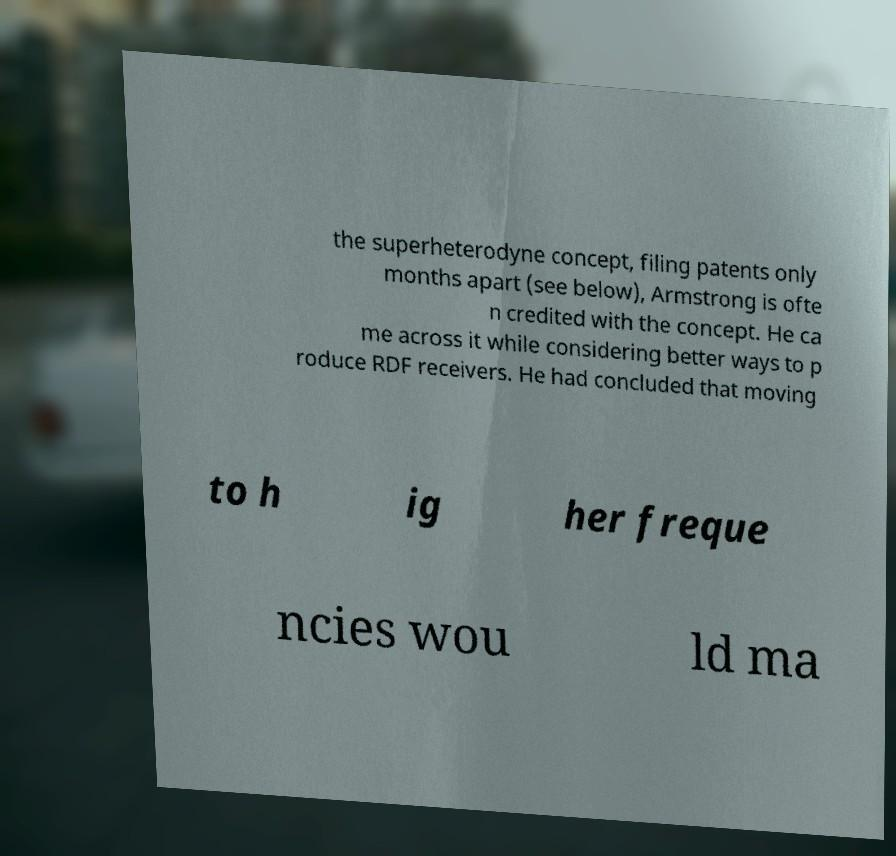Can you accurately transcribe the text from the provided image for me? the superheterodyne concept, filing patents only months apart (see below), Armstrong is ofte n credited with the concept. He ca me across it while considering better ways to p roduce RDF receivers. He had concluded that moving to h ig her freque ncies wou ld ma 